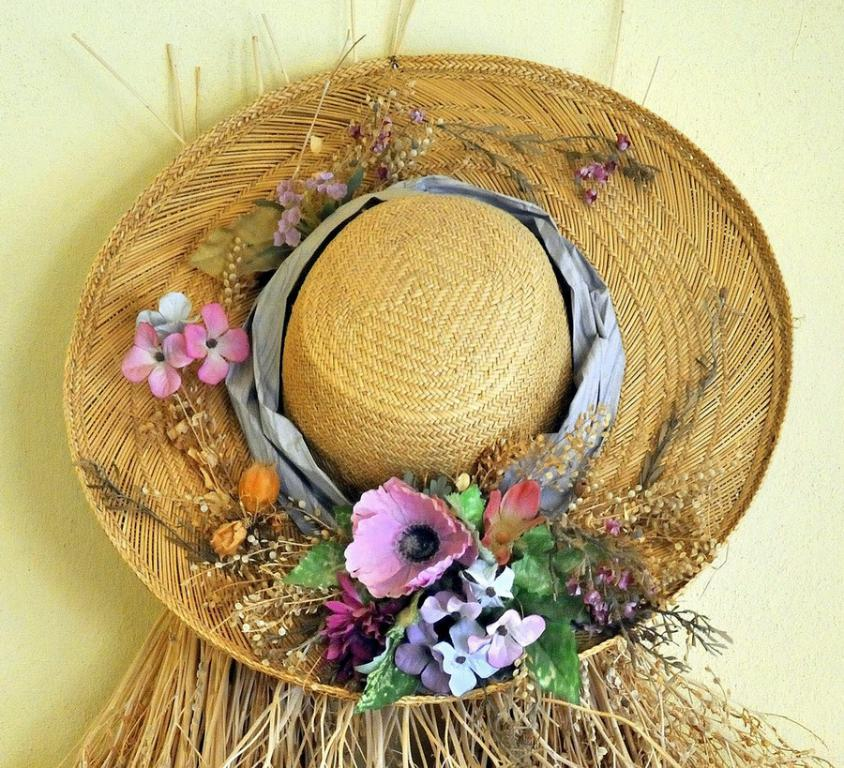What is present on the wall in the image? There is a hat in the image, and it is attached to a wall. How is the hat decorated? The hat is decorated with flowers and other objects. How many boys are holding the vase in the image? There is no vase or boys present in the image; it only features a hat decorated with flowers and other objects. 